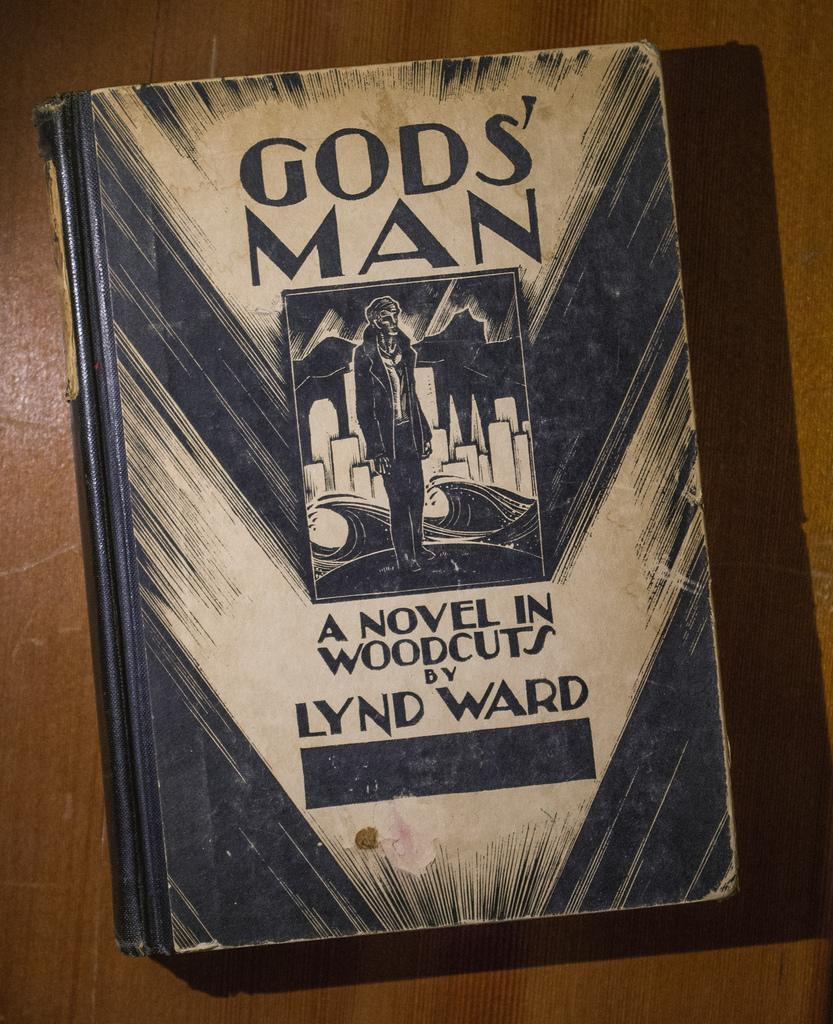<image>
Create a compact narrative representing the image presented. A sketched book cover for A Novel in Woodcuts by Lynd Ward. 